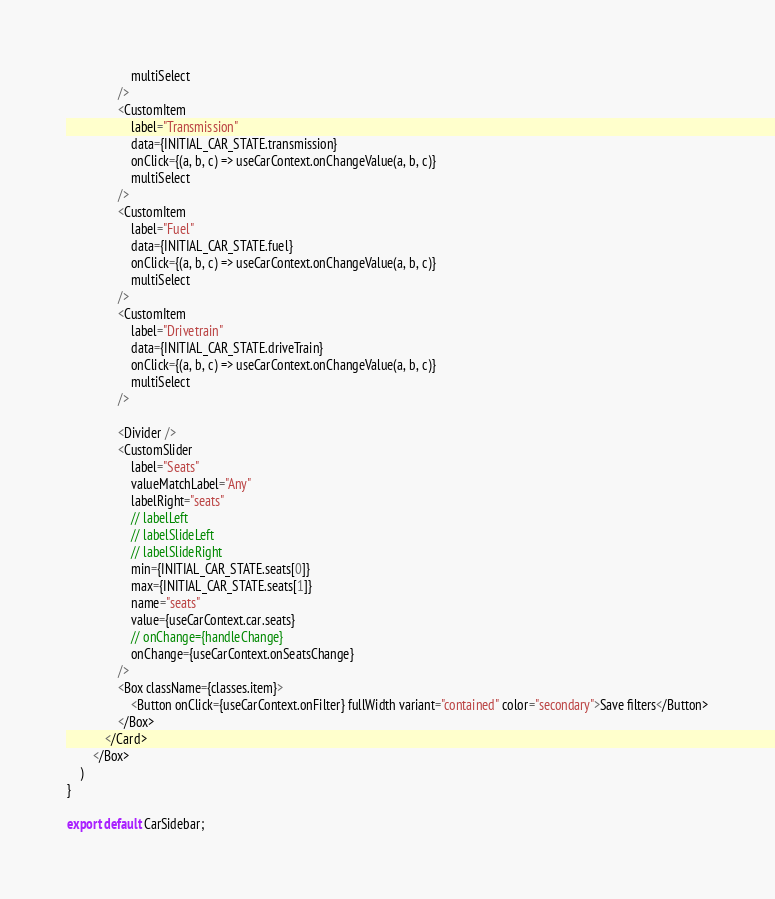Convert code to text. <code><loc_0><loc_0><loc_500><loc_500><_JavaScript_>                    multiSelect
                />
                <CustomItem
                    label="Transmission"
                    data={INITIAL_CAR_STATE.transmission}
                    onClick={(a, b, c) => useCarContext.onChangeValue(a, b, c)}
                    multiSelect
                />
                <CustomItem
                    label="Fuel"
                    data={INITIAL_CAR_STATE.fuel}
                    onClick={(a, b, c) => useCarContext.onChangeValue(a, b, c)}
                    multiSelect
                />
                <CustomItem
                    label="Drivetrain"
                    data={INITIAL_CAR_STATE.driveTrain}
                    onClick={(a, b, c) => useCarContext.onChangeValue(a, b, c)}
                    multiSelect
                />

                <Divider />
                <CustomSlider
                    label="Seats"
                    valueMatchLabel="Any"
                    labelRight="seats"
                    // labelLeft
                    // labelSlideLeft
                    // labelSlideRight
                    min={INITIAL_CAR_STATE.seats[0]}
                    max={INITIAL_CAR_STATE.seats[1]}
                    name="seats"
                    value={useCarContext.car.seats}
                    // onChange={handleChange}
                    onChange={useCarContext.onSeatsChange}
                />
                <Box className={classes.item}>
                    <Button onClick={useCarContext.onFilter} fullWidth variant="contained" color="secondary">Save filters</Button>
                </Box>
            </Card>
        </Box>
    )
}

export default CarSidebar;</code> 